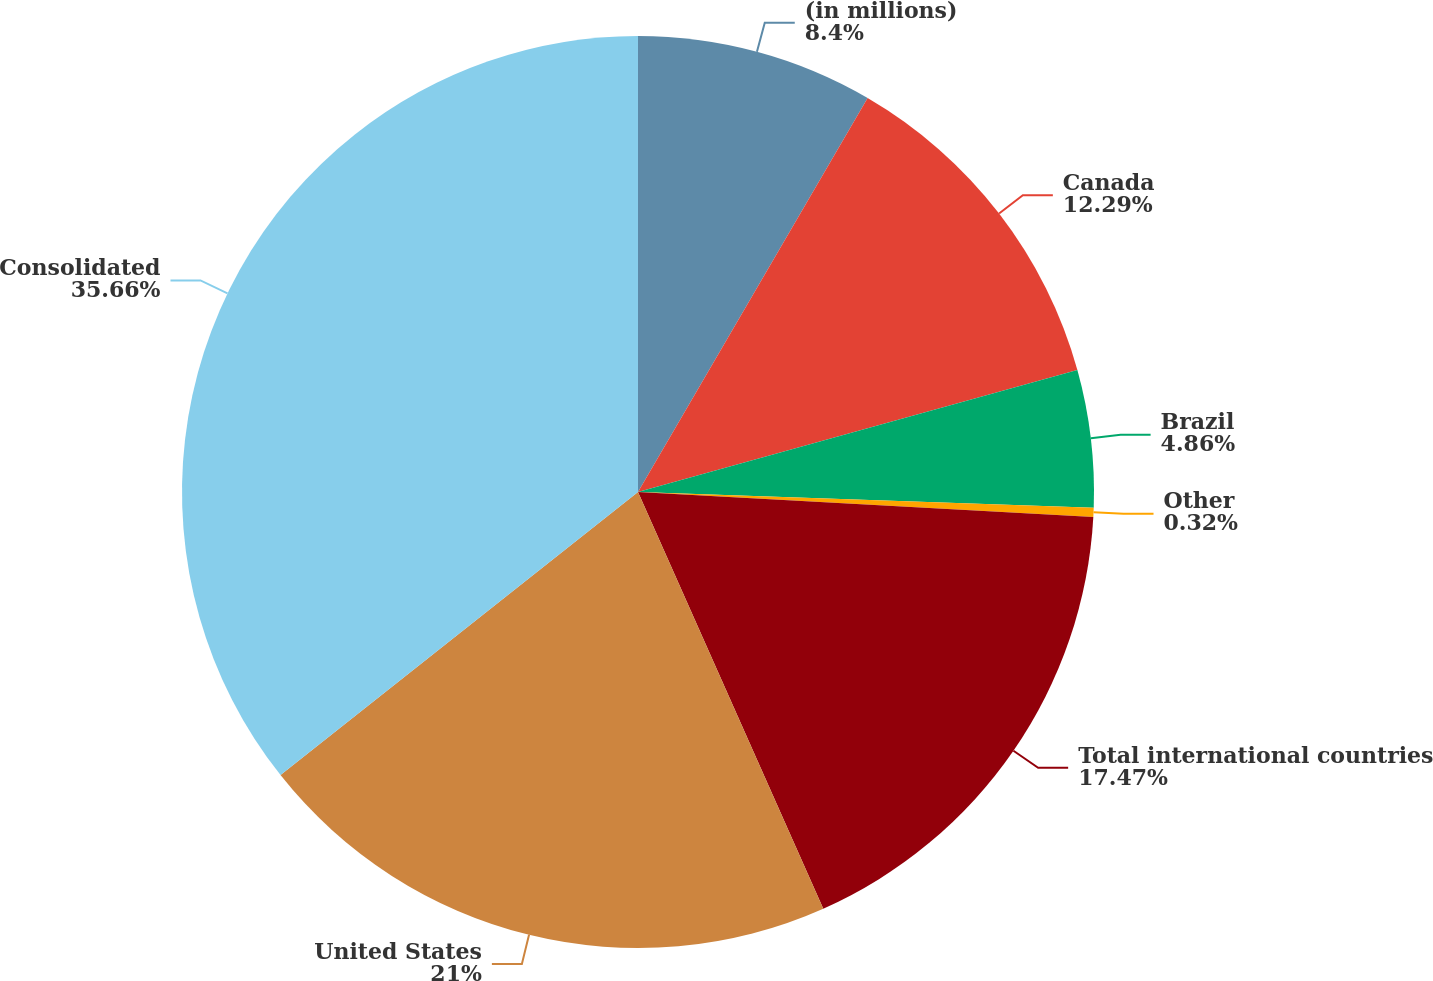Convert chart to OTSL. <chart><loc_0><loc_0><loc_500><loc_500><pie_chart><fcel>(in millions)<fcel>Canada<fcel>Brazil<fcel>Other<fcel>Total international countries<fcel>United States<fcel>Consolidated<nl><fcel>8.4%<fcel>12.29%<fcel>4.86%<fcel>0.32%<fcel>17.47%<fcel>21.0%<fcel>35.66%<nl></chart> 